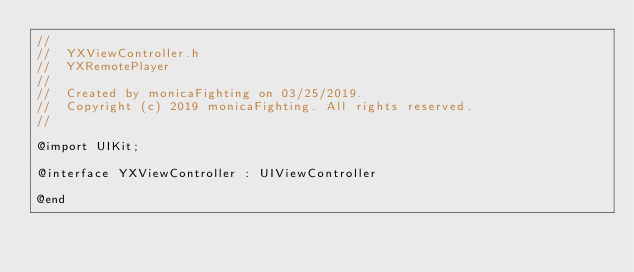<code> <loc_0><loc_0><loc_500><loc_500><_C_>//
//  YXViewController.h
//  YXRemotePlayer
//
//  Created by monicaFighting on 03/25/2019.
//  Copyright (c) 2019 monicaFighting. All rights reserved.
//

@import UIKit;

@interface YXViewController : UIViewController

@end
</code> 